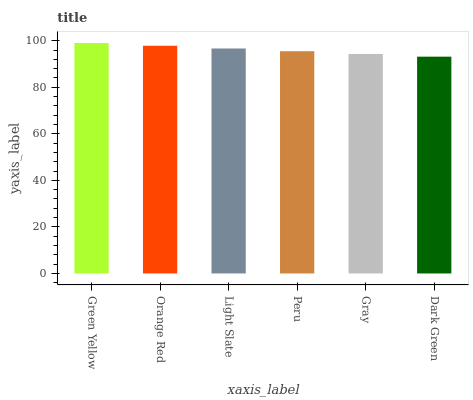Is Orange Red the minimum?
Answer yes or no. No. Is Orange Red the maximum?
Answer yes or no. No. Is Green Yellow greater than Orange Red?
Answer yes or no. Yes. Is Orange Red less than Green Yellow?
Answer yes or no. Yes. Is Orange Red greater than Green Yellow?
Answer yes or no. No. Is Green Yellow less than Orange Red?
Answer yes or no. No. Is Light Slate the high median?
Answer yes or no. Yes. Is Peru the low median?
Answer yes or no. Yes. Is Peru the high median?
Answer yes or no. No. Is Green Yellow the low median?
Answer yes or no. No. 